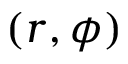Convert formula to latex. <formula><loc_0><loc_0><loc_500><loc_500>( r , \phi )</formula> 